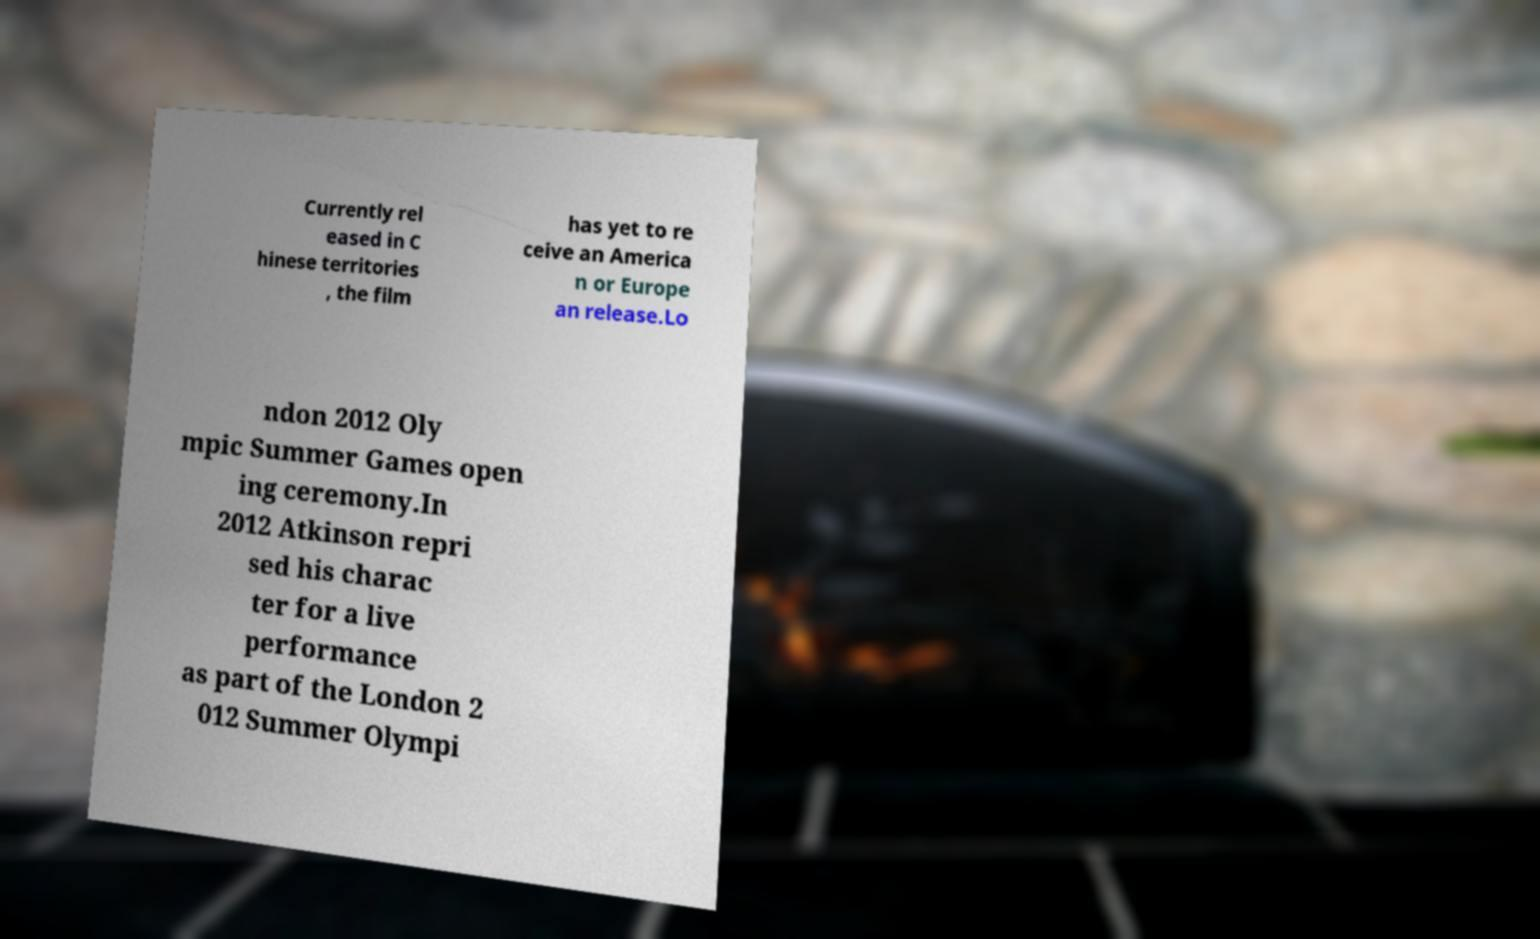What messages or text are displayed in this image? I need them in a readable, typed format. Currently rel eased in C hinese territories , the film has yet to re ceive an America n or Europe an release.Lo ndon 2012 Oly mpic Summer Games open ing ceremony.In 2012 Atkinson repri sed his charac ter for a live performance as part of the London 2 012 Summer Olympi 